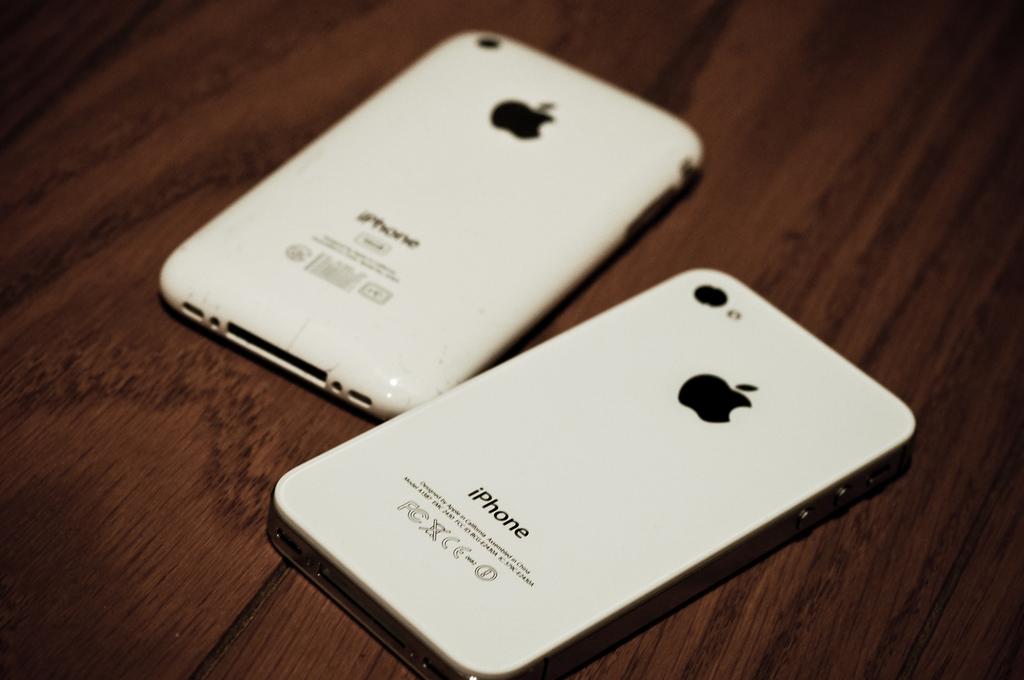What is the brand of this phone?
Provide a succinct answer. Iphone. 